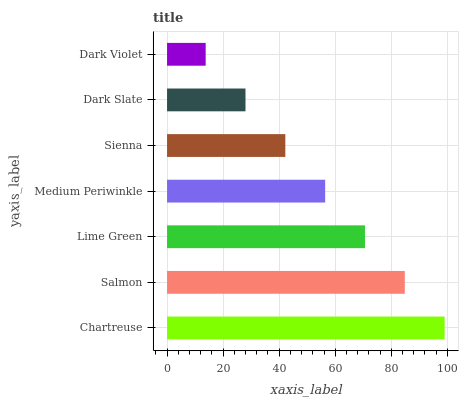Is Dark Violet the minimum?
Answer yes or no. Yes. Is Chartreuse the maximum?
Answer yes or no. Yes. Is Salmon the minimum?
Answer yes or no. No. Is Salmon the maximum?
Answer yes or no. No. Is Chartreuse greater than Salmon?
Answer yes or no. Yes. Is Salmon less than Chartreuse?
Answer yes or no. Yes. Is Salmon greater than Chartreuse?
Answer yes or no. No. Is Chartreuse less than Salmon?
Answer yes or no. No. Is Medium Periwinkle the high median?
Answer yes or no. Yes. Is Medium Periwinkle the low median?
Answer yes or no. Yes. Is Sienna the high median?
Answer yes or no. No. Is Chartreuse the low median?
Answer yes or no. No. 